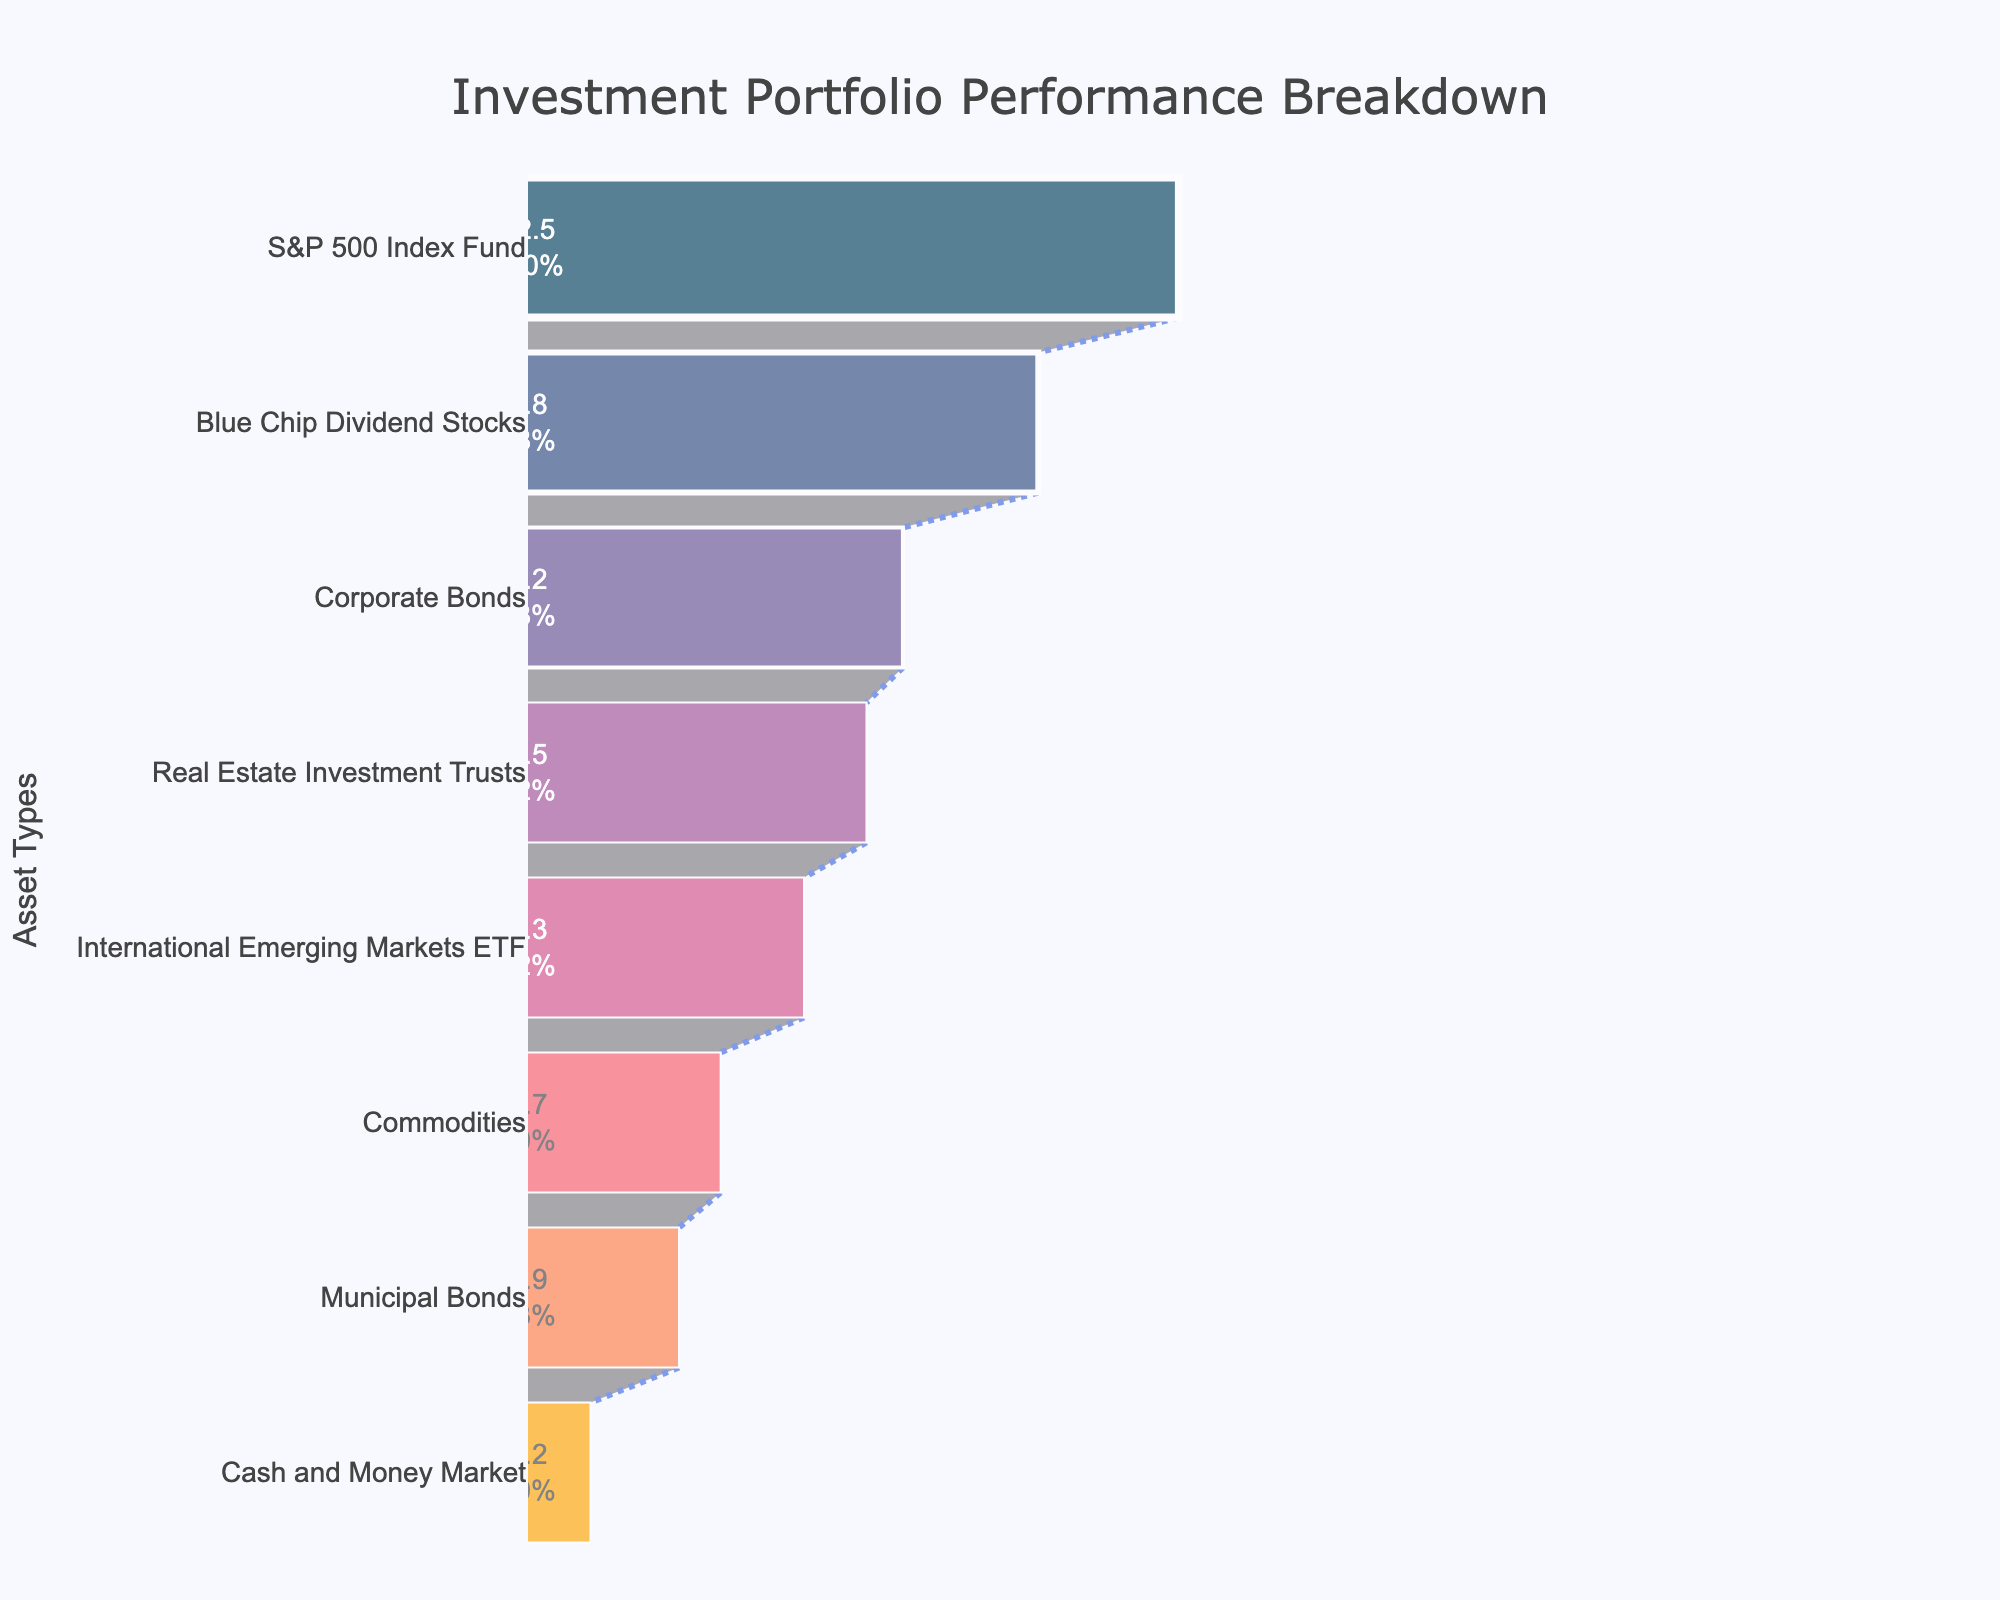What is the highest performing asset? By examining the top section of the Funnel Chart, the S&P 500 Index Fund is located at the highest point with the performance value of 12.5%.
Answer: S&P 500 Index Fund What is the performance of Municipal Bonds? In the Funnel Chart, the Municipal Bonds are situated towards the lower end with a performance value displayed next to it, which is 2.9%.
Answer: 2.9% Which asset has the lowest performance? The bottom-most section of the Funnel Chart represents the lowest-performing asset, which is Cash and Money Market with a performance value of 1.2%.
Answer: Cash and Money Market How many asset categories are displayed in the Funnel Chart? By counting each distinct section in the Funnel Chart, there are a total of 8 different asset categories represented.
Answer: 8 What is the combined performance percentage of Blue Chip Dividend Stocks and International Emerging Markets ETF? Blue Chip Dividend Stocks have a performance of 9.8% and International Emerging Markets ETF have a performance of 5.3%. Summing these values gives 9.8 + 5.3 = 15.1%.
Answer: 15.1% Which asset performs better: Real Estate Investment Trusts or Commodities? By comparing their positions in the Funnel Chart, Real Estate Investment Trusts are above Commodities, indicating a higher performance. The performance values are 6.5% for Real Estate Investment Trusts and 3.7% for Commodities.
Answer: Real Estate Investment Trusts What percentage of the initial performance does the Corporate Bonds section represent? Corporate Bonds have a performance of 7.2%. When compared to the initial performance (S&P 500 Index Fund at 12.5%), the percentage is calculated as (7.2 / 12.5) * 100, which is approximately 57.6%.
Answer: Approximately 57.6% What is the performance difference between the highest and lowest performing assets? The S&P 500 Index Fund performs at 12.5% while Cash and Money Market performs at 1.2%. The difference is calculated as 12.5 - 1.2 = 11.3%.
Answer: 11.3% Which two assets have performances closest to each other? By closely examining the displayed performance values in the Funnel Chart, the performances of Corporate Bonds (7.2%) and Real Estate Investment Trusts (6.5%) are closest to each other with a difference of 0.7%.
Answer: Corporate Bonds and Real Estate Investment Trusts What are the median performance and how is it determined from the Funnel Chart? To determine the median performance, the values need to be ordered: 12.5, 9.8, 7.2, 6.5, 5.3, 3.7, 2.9, 1.2. Since there are 8 values, the median is the average of the 4th and 5th values, (6.5 + 5.3)/2 = 5.9%.
Answer: 5.9% 